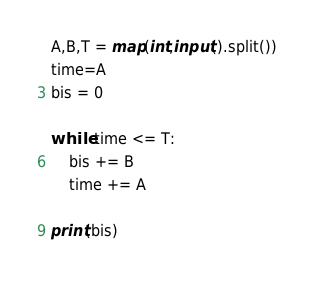<code> <loc_0><loc_0><loc_500><loc_500><_Python_>A,B,T = map(int,input().split())
time=A
bis = 0

while time <= T:
    bis += B
    time += A

print(bis)
</code> 